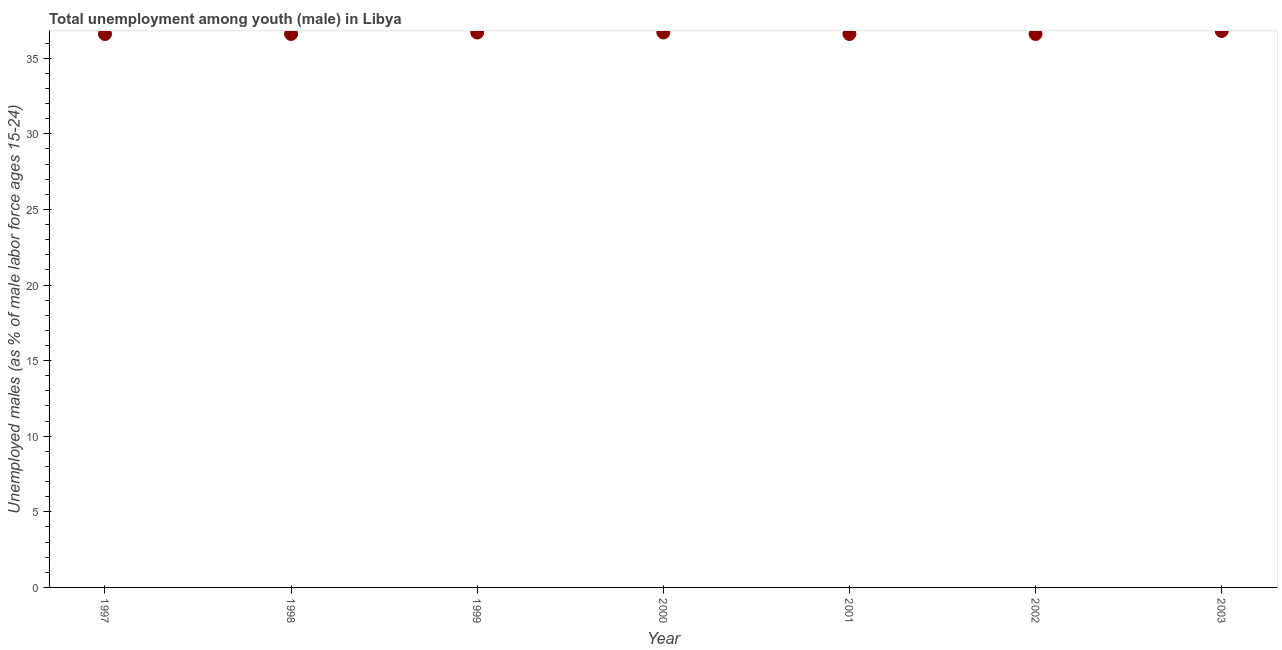What is the unemployed male youth population in 2003?
Your response must be concise. 36.8. Across all years, what is the maximum unemployed male youth population?
Provide a short and direct response. 36.8. Across all years, what is the minimum unemployed male youth population?
Your answer should be compact. 36.6. In which year was the unemployed male youth population minimum?
Your answer should be compact. 1997. What is the sum of the unemployed male youth population?
Ensure brevity in your answer.  256.6. What is the difference between the unemployed male youth population in 1998 and 2003?
Keep it short and to the point. -0.2. What is the average unemployed male youth population per year?
Your response must be concise. 36.66. What is the median unemployed male youth population?
Offer a terse response. 36.6. In how many years, is the unemployed male youth population greater than 16 %?
Your response must be concise. 7. Do a majority of the years between 2000 and 2002 (inclusive) have unemployed male youth population greater than 2 %?
Give a very brief answer. Yes. What is the ratio of the unemployed male youth population in 2002 to that in 2003?
Your answer should be very brief. 0.99. Is the difference between the unemployed male youth population in 2000 and 2001 greater than the difference between any two years?
Provide a succinct answer. No. What is the difference between the highest and the second highest unemployed male youth population?
Offer a terse response. 0.1. Is the sum of the unemployed male youth population in 1997 and 2001 greater than the maximum unemployed male youth population across all years?
Offer a terse response. Yes. What is the difference between the highest and the lowest unemployed male youth population?
Your answer should be very brief. 0.2. In how many years, is the unemployed male youth population greater than the average unemployed male youth population taken over all years?
Your answer should be very brief. 3. Does the unemployed male youth population monotonically increase over the years?
Your answer should be very brief. No. What is the difference between two consecutive major ticks on the Y-axis?
Your answer should be compact. 5. Are the values on the major ticks of Y-axis written in scientific E-notation?
Your response must be concise. No. What is the title of the graph?
Offer a very short reply. Total unemployment among youth (male) in Libya. What is the label or title of the Y-axis?
Ensure brevity in your answer.  Unemployed males (as % of male labor force ages 15-24). What is the Unemployed males (as % of male labor force ages 15-24) in 1997?
Your response must be concise. 36.6. What is the Unemployed males (as % of male labor force ages 15-24) in 1998?
Make the answer very short. 36.6. What is the Unemployed males (as % of male labor force ages 15-24) in 1999?
Offer a terse response. 36.7. What is the Unemployed males (as % of male labor force ages 15-24) in 2000?
Ensure brevity in your answer.  36.7. What is the Unemployed males (as % of male labor force ages 15-24) in 2001?
Your response must be concise. 36.6. What is the Unemployed males (as % of male labor force ages 15-24) in 2002?
Make the answer very short. 36.6. What is the Unemployed males (as % of male labor force ages 15-24) in 2003?
Your answer should be compact. 36.8. What is the difference between the Unemployed males (as % of male labor force ages 15-24) in 1997 and 1998?
Ensure brevity in your answer.  0. What is the difference between the Unemployed males (as % of male labor force ages 15-24) in 1997 and 2003?
Make the answer very short. -0.2. What is the difference between the Unemployed males (as % of male labor force ages 15-24) in 1998 and 2000?
Provide a succinct answer. -0.1. What is the difference between the Unemployed males (as % of male labor force ages 15-24) in 1998 and 2002?
Your response must be concise. 0. What is the difference between the Unemployed males (as % of male labor force ages 15-24) in 1999 and 2000?
Ensure brevity in your answer.  0. What is the difference between the Unemployed males (as % of male labor force ages 15-24) in 1999 and 2003?
Offer a terse response. -0.1. What is the difference between the Unemployed males (as % of male labor force ages 15-24) in 2000 and 2003?
Keep it short and to the point. -0.1. What is the difference between the Unemployed males (as % of male labor force ages 15-24) in 2001 and 2002?
Give a very brief answer. 0. What is the difference between the Unemployed males (as % of male labor force ages 15-24) in 2001 and 2003?
Keep it short and to the point. -0.2. What is the difference between the Unemployed males (as % of male labor force ages 15-24) in 2002 and 2003?
Provide a succinct answer. -0.2. What is the ratio of the Unemployed males (as % of male labor force ages 15-24) in 1997 to that in 1998?
Make the answer very short. 1. What is the ratio of the Unemployed males (as % of male labor force ages 15-24) in 1997 to that in 1999?
Ensure brevity in your answer.  1. What is the ratio of the Unemployed males (as % of male labor force ages 15-24) in 1997 to that in 2000?
Keep it short and to the point. 1. What is the ratio of the Unemployed males (as % of male labor force ages 15-24) in 1997 to that in 2001?
Your response must be concise. 1. What is the ratio of the Unemployed males (as % of male labor force ages 15-24) in 1997 to that in 2003?
Keep it short and to the point. 0.99. What is the ratio of the Unemployed males (as % of male labor force ages 15-24) in 1998 to that in 1999?
Offer a very short reply. 1. What is the ratio of the Unemployed males (as % of male labor force ages 15-24) in 1998 to that in 2000?
Make the answer very short. 1. What is the ratio of the Unemployed males (as % of male labor force ages 15-24) in 1998 to that in 2003?
Offer a terse response. 0.99. What is the ratio of the Unemployed males (as % of male labor force ages 15-24) in 1999 to that in 2001?
Provide a short and direct response. 1. What is the ratio of the Unemployed males (as % of male labor force ages 15-24) in 1999 to that in 2003?
Provide a succinct answer. 1. What is the ratio of the Unemployed males (as % of male labor force ages 15-24) in 2000 to that in 2001?
Offer a very short reply. 1. What is the ratio of the Unemployed males (as % of male labor force ages 15-24) in 2000 to that in 2003?
Make the answer very short. 1. 